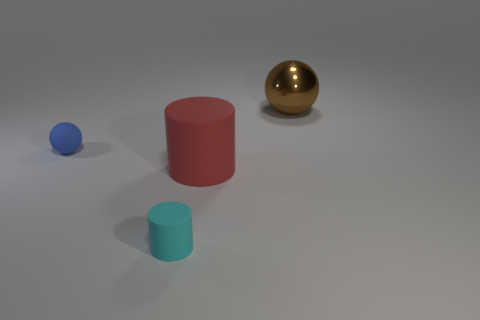Are there any other things that are made of the same material as the large brown sphere?
Ensure brevity in your answer.  No. What is the shape of the object that is both behind the red cylinder and on the left side of the large red thing?
Your response must be concise. Sphere. Are there any tiny brown shiny blocks?
Offer a terse response. No. What is the material of the cyan thing that is the same shape as the red thing?
Your answer should be very brief. Rubber. The large object to the right of the big thing to the left of the object to the right of the red rubber cylinder is what shape?
Keep it short and to the point. Sphere. How many other things are the same shape as the big matte thing?
Your answer should be very brief. 1. Do the tiny rubber object left of the cyan object and the big thing in front of the tiny blue object have the same color?
Make the answer very short. No. There is a cyan thing that is the same size as the rubber ball; what material is it?
Offer a terse response. Rubber. Are there any objects that have the same size as the brown metal ball?
Make the answer very short. Yes. Is the number of cylinders that are to the right of the cyan thing less than the number of cyan rubber objects?
Your answer should be compact. No. 